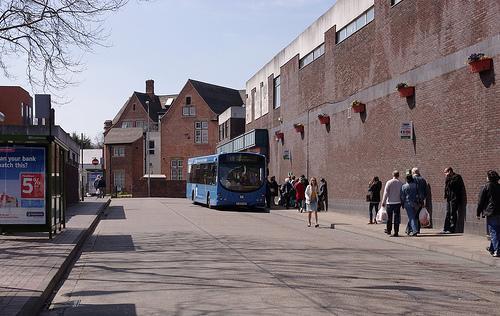How many buses are there?
Give a very brief answer. 1. How many people are walking in the street?
Give a very brief answer. 1. 